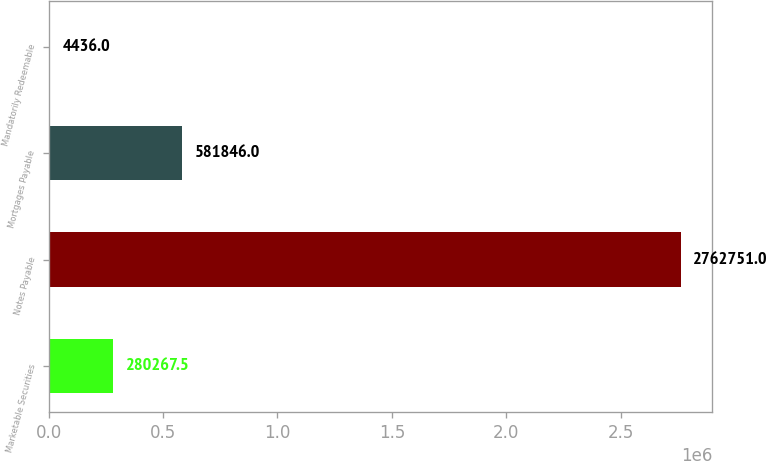Convert chart to OTSL. <chart><loc_0><loc_0><loc_500><loc_500><bar_chart><fcel>Marketable Securities<fcel>Notes Payable<fcel>Mortgages Payable<fcel>Mandatorily Redeemable<nl><fcel>280268<fcel>2.76275e+06<fcel>581846<fcel>4436<nl></chart> 